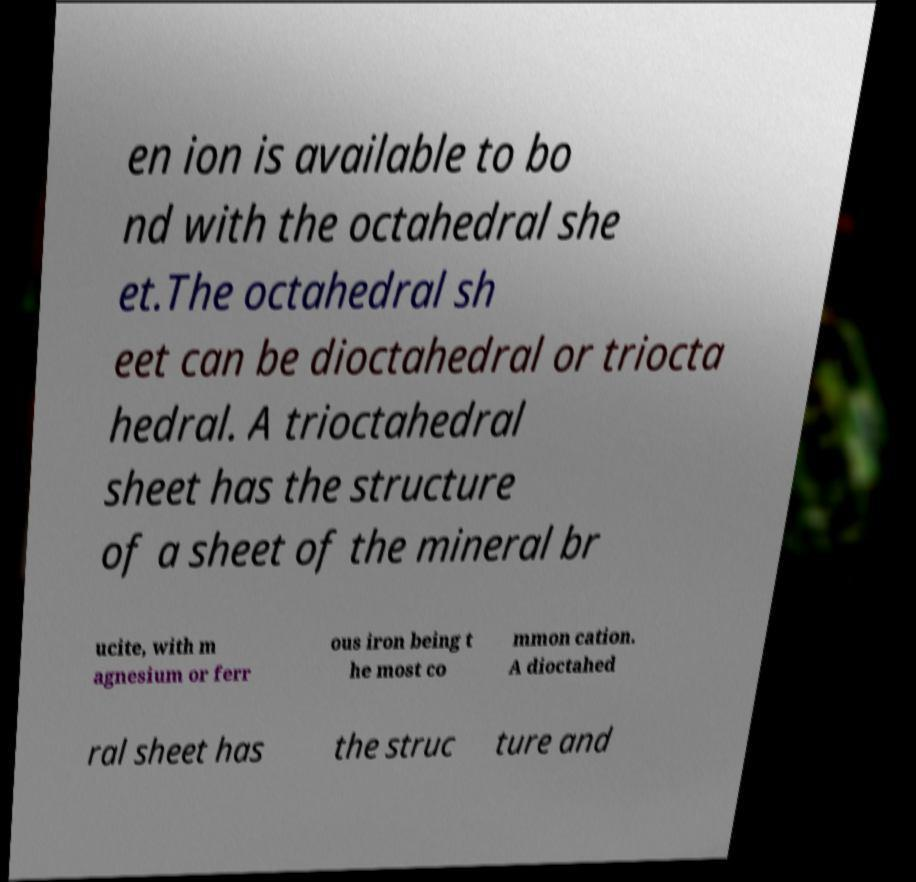For documentation purposes, I need the text within this image transcribed. Could you provide that? en ion is available to bo nd with the octahedral she et.The octahedral sh eet can be dioctahedral or triocta hedral. A trioctahedral sheet has the structure of a sheet of the mineral br ucite, with m agnesium or ferr ous iron being t he most co mmon cation. A dioctahed ral sheet has the struc ture and 